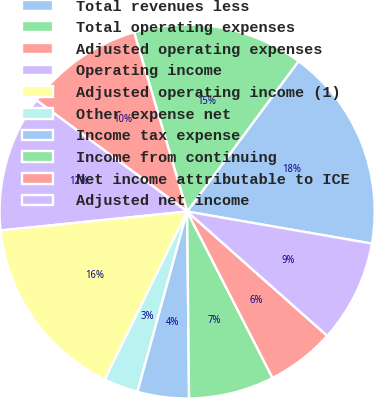<chart> <loc_0><loc_0><loc_500><loc_500><pie_chart><fcel>Total revenues less<fcel>Total operating expenses<fcel>Adjusted operating expenses<fcel>Operating income<fcel>Adjusted operating income (1)<fcel>Other expense net<fcel>Income tax expense<fcel>Income from continuing<fcel>Net income attributable to ICE<fcel>Adjusted net income<nl><fcel>17.62%<fcel>14.69%<fcel>10.29%<fcel>11.76%<fcel>16.15%<fcel>2.97%<fcel>4.43%<fcel>7.36%<fcel>5.9%<fcel>8.83%<nl></chart> 